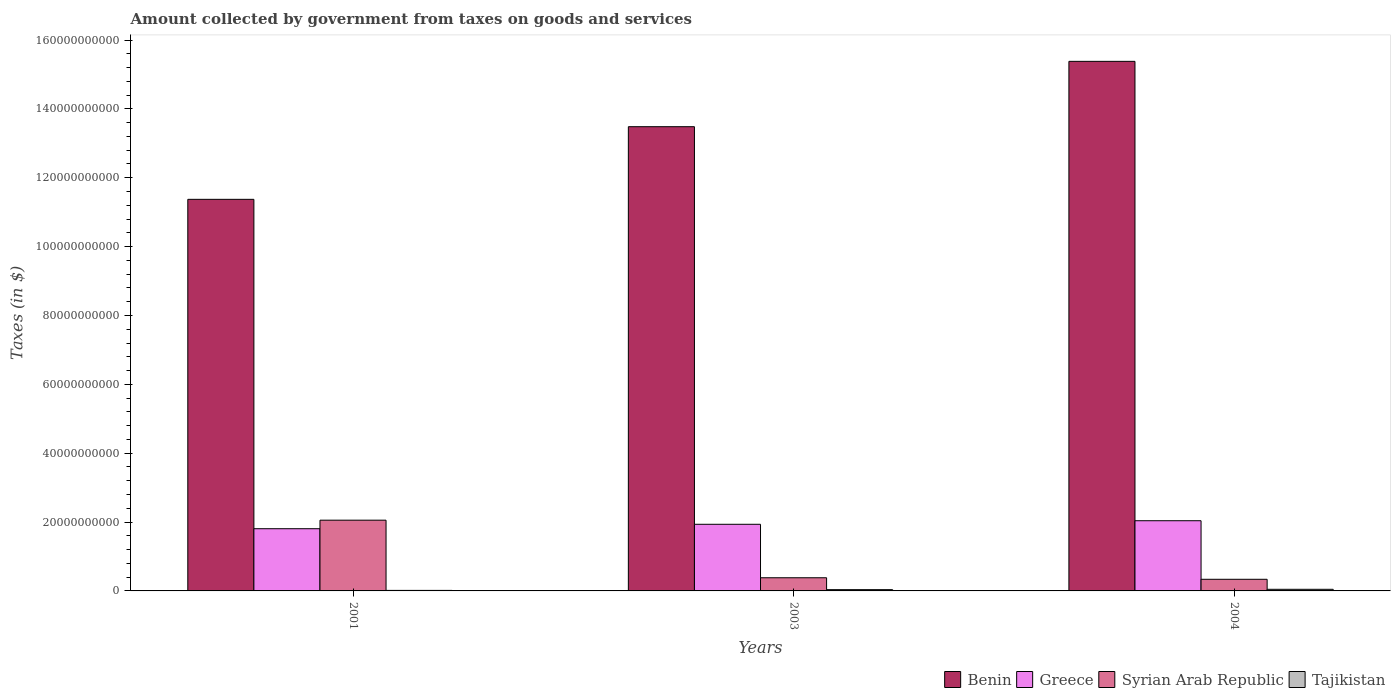Are the number of bars per tick equal to the number of legend labels?
Keep it short and to the point. Yes. How many bars are there on the 1st tick from the left?
Your answer should be compact. 4. In how many cases, is the number of bars for a given year not equal to the number of legend labels?
Make the answer very short. 0. What is the amount collected by government from taxes on goods and services in Tajikistan in 2003?
Your response must be concise. 3.68e+08. Across all years, what is the maximum amount collected by government from taxes on goods and services in Benin?
Make the answer very short. 1.54e+11. Across all years, what is the minimum amount collected by government from taxes on goods and services in Syrian Arab Republic?
Provide a short and direct response. 3.38e+09. In which year was the amount collected by government from taxes on goods and services in Syrian Arab Republic maximum?
Provide a short and direct response. 2001. In which year was the amount collected by government from taxes on goods and services in Syrian Arab Republic minimum?
Keep it short and to the point. 2004. What is the total amount collected by government from taxes on goods and services in Syrian Arab Republic in the graph?
Offer a terse response. 2.77e+1. What is the difference between the amount collected by government from taxes on goods and services in Tajikistan in 2003 and that in 2004?
Offer a very short reply. -1.03e+08. What is the difference between the amount collected by government from taxes on goods and services in Tajikistan in 2003 and the amount collected by government from taxes on goods and services in Greece in 2004?
Provide a short and direct response. -2.00e+1. What is the average amount collected by government from taxes on goods and services in Syrian Arab Republic per year?
Your answer should be very brief. 9.25e+09. In the year 2001, what is the difference between the amount collected by government from taxes on goods and services in Benin and amount collected by government from taxes on goods and services in Tajikistan?
Your answer should be compact. 1.14e+11. What is the ratio of the amount collected by government from taxes on goods and services in Tajikistan in 2001 to that in 2003?
Your response must be concise. 0.42. What is the difference between the highest and the second highest amount collected by government from taxes on goods and services in Benin?
Give a very brief answer. 1.90e+1. What is the difference between the highest and the lowest amount collected by government from taxes on goods and services in Tajikistan?
Your answer should be very brief. 3.17e+08. In how many years, is the amount collected by government from taxes on goods and services in Greece greater than the average amount collected by government from taxes on goods and services in Greece taken over all years?
Your response must be concise. 2. Is the sum of the amount collected by government from taxes on goods and services in Greece in 2001 and 2003 greater than the maximum amount collected by government from taxes on goods and services in Syrian Arab Republic across all years?
Your answer should be very brief. Yes. Is it the case that in every year, the sum of the amount collected by government from taxes on goods and services in Syrian Arab Republic and amount collected by government from taxes on goods and services in Benin is greater than the sum of amount collected by government from taxes on goods and services in Tajikistan and amount collected by government from taxes on goods and services in Greece?
Provide a short and direct response. Yes. What does the 4th bar from the left in 2004 represents?
Offer a terse response. Tajikistan. What does the 1st bar from the right in 2003 represents?
Your answer should be very brief. Tajikistan. Is it the case that in every year, the sum of the amount collected by government from taxes on goods and services in Greece and amount collected by government from taxes on goods and services in Benin is greater than the amount collected by government from taxes on goods and services in Syrian Arab Republic?
Make the answer very short. Yes. How many bars are there?
Offer a very short reply. 12. Are all the bars in the graph horizontal?
Provide a short and direct response. No. How many years are there in the graph?
Make the answer very short. 3. What is the difference between two consecutive major ticks on the Y-axis?
Offer a terse response. 2.00e+1. Does the graph contain any zero values?
Your response must be concise. No. Does the graph contain grids?
Keep it short and to the point. No. Where does the legend appear in the graph?
Keep it short and to the point. Bottom right. How are the legend labels stacked?
Make the answer very short. Horizontal. What is the title of the graph?
Give a very brief answer. Amount collected by government from taxes on goods and services. What is the label or title of the X-axis?
Your response must be concise. Years. What is the label or title of the Y-axis?
Ensure brevity in your answer.  Taxes (in $). What is the Taxes (in $) in Benin in 2001?
Your answer should be compact. 1.14e+11. What is the Taxes (in $) in Greece in 2001?
Provide a short and direct response. 1.81e+1. What is the Taxes (in $) of Syrian Arab Republic in 2001?
Offer a terse response. 2.05e+1. What is the Taxes (in $) of Tajikistan in 2001?
Provide a short and direct response. 1.53e+08. What is the Taxes (in $) in Benin in 2003?
Keep it short and to the point. 1.35e+11. What is the Taxes (in $) of Greece in 2003?
Make the answer very short. 1.94e+1. What is the Taxes (in $) in Syrian Arab Republic in 2003?
Provide a succinct answer. 3.82e+09. What is the Taxes (in $) of Tajikistan in 2003?
Make the answer very short. 3.68e+08. What is the Taxes (in $) of Benin in 2004?
Ensure brevity in your answer.  1.54e+11. What is the Taxes (in $) of Greece in 2004?
Make the answer very short. 2.04e+1. What is the Taxes (in $) of Syrian Arab Republic in 2004?
Provide a short and direct response. 3.38e+09. What is the Taxes (in $) in Tajikistan in 2004?
Make the answer very short. 4.71e+08. Across all years, what is the maximum Taxes (in $) in Benin?
Provide a succinct answer. 1.54e+11. Across all years, what is the maximum Taxes (in $) of Greece?
Give a very brief answer. 2.04e+1. Across all years, what is the maximum Taxes (in $) in Syrian Arab Republic?
Your answer should be very brief. 2.05e+1. Across all years, what is the maximum Taxes (in $) of Tajikistan?
Provide a succinct answer. 4.71e+08. Across all years, what is the minimum Taxes (in $) in Benin?
Offer a very short reply. 1.14e+11. Across all years, what is the minimum Taxes (in $) of Greece?
Offer a terse response. 1.81e+1. Across all years, what is the minimum Taxes (in $) of Syrian Arab Republic?
Your answer should be very brief. 3.38e+09. Across all years, what is the minimum Taxes (in $) of Tajikistan?
Your response must be concise. 1.53e+08. What is the total Taxes (in $) in Benin in the graph?
Your answer should be compact. 4.02e+11. What is the total Taxes (in $) of Greece in the graph?
Give a very brief answer. 5.78e+1. What is the total Taxes (in $) of Syrian Arab Republic in the graph?
Your answer should be very brief. 2.77e+1. What is the total Taxes (in $) in Tajikistan in the graph?
Give a very brief answer. 9.92e+08. What is the difference between the Taxes (in $) in Benin in 2001 and that in 2003?
Keep it short and to the point. -2.11e+1. What is the difference between the Taxes (in $) of Greece in 2001 and that in 2003?
Ensure brevity in your answer.  -1.29e+09. What is the difference between the Taxes (in $) in Syrian Arab Republic in 2001 and that in 2003?
Provide a short and direct response. 1.67e+1. What is the difference between the Taxes (in $) in Tajikistan in 2001 and that in 2003?
Ensure brevity in your answer.  -2.14e+08. What is the difference between the Taxes (in $) of Benin in 2001 and that in 2004?
Your answer should be compact. -4.01e+1. What is the difference between the Taxes (in $) of Greece in 2001 and that in 2004?
Provide a short and direct response. -2.32e+09. What is the difference between the Taxes (in $) in Syrian Arab Republic in 2001 and that in 2004?
Your answer should be compact. 1.72e+1. What is the difference between the Taxes (in $) in Tajikistan in 2001 and that in 2004?
Ensure brevity in your answer.  -3.17e+08. What is the difference between the Taxes (in $) of Benin in 2003 and that in 2004?
Offer a very short reply. -1.90e+1. What is the difference between the Taxes (in $) of Greece in 2003 and that in 2004?
Your answer should be very brief. -1.03e+09. What is the difference between the Taxes (in $) of Syrian Arab Republic in 2003 and that in 2004?
Offer a very short reply. 4.42e+08. What is the difference between the Taxes (in $) in Tajikistan in 2003 and that in 2004?
Offer a terse response. -1.03e+08. What is the difference between the Taxes (in $) of Benin in 2001 and the Taxes (in $) of Greece in 2003?
Provide a succinct answer. 9.44e+1. What is the difference between the Taxes (in $) in Benin in 2001 and the Taxes (in $) in Syrian Arab Republic in 2003?
Your answer should be compact. 1.10e+11. What is the difference between the Taxes (in $) in Benin in 2001 and the Taxes (in $) in Tajikistan in 2003?
Your response must be concise. 1.13e+11. What is the difference between the Taxes (in $) of Greece in 2001 and the Taxes (in $) of Syrian Arab Republic in 2003?
Keep it short and to the point. 1.42e+1. What is the difference between the Taxes (in $) of Greece in 2001 and the Taxes (in $) of Tajikistan in 2003?
Offer a very short reply. 1.77e+1. What is the difference between the Taxes (in $) in Syrian Arab Republic in 2001 and the Taxes (in $) in Tajikistan in 2003?
Your answer should be very brief. 2.02e+1. What is the difference between the Taxes (in $) of Benin in 2001 and the Taxes (in $) of Greece in 2004?
Give a very brief answer. 9.33e+1. What is the difference between the Taxes (in $) in Benin in 2001 and the Taxes (in $) in Syrian Arab Republic in 2004?
Provide a succinct answer. 1.10e+11. What is the difference between the Taxes (in $) in Benin in 2001 and the Taxes (in $) in Tajikistan in 2004?
Your answer should be very brief. 1.13e+11. What is the difference between the Taxes (in $) of Greece in 2001 and the Taxes (in $) of Syrian Arab Republic in 2004?
Give a very brief answer. 1.47e+1. What is the difference between the Taxes (in $) in Greece in 2001 and the Taxes (in $) in Tajikistan in 2004?
Keep it short and to the point. 1.76e+1. What is the difference between the Taxes (in $) of Syrian Arab Republic in 2001 and the Taxes (in $) of Tajikistan in 2004?
Make the answer very short. 2.01e+1. What is the difference between the Taxes (in $) of Benin in 2003 and the Taxes (in $) of Greece in 2004?
Keep it short and to the point. 1.14e+11. What is the difference between the Taxes (in $) of Benin in 2003 and the Taxes (in $) of Syrian Arab Republic in 2004?
Give a very brief answer. 1.31e+11. What is the difference between the Taxes (in $) in Benin in 2003 and the Taxes (in $) in Tajikistan in 2004?
Offer a very short reply. 1.34e+11. What is the difference between the Taxes (in $) in Greece in 2003 and the Taxes (in $) in Syrian Arab Republic in 2004?
Provide a succinct answer. 1.60e+1. What is the difference between the Taxes (in $) of Greece in 2003 and the Taxes (in $) of Tajikistan in 2004?
Offer a very short reply. 1.89e+1. What is the difference between the Taxes (in $) in Syrian Arab Republic in 2003 and the Taxes (in $) in Tajikistan in 2004?
Keep it short and to the point. 3.35e+09. What is the average Taxes (in $) in Benin per year?
Your response must be concise. 1.34e+11. What is the average Taxes (in $) in Greece per year?
Give a very brief answer. 1.93e+1. What is the average Taxes (in $) in Syrian Arab Republic per year?
Your response must be concise. 9.25e+09. What is the average Taxes (in $) of Tajikistan per year?
Keep it short and to the point. 3.31e+08. In the year 2001, what is the difference between the Taxes (in $) of Benin and Taxes (in $) of Greece?
Offer a very short reply. 9.57e+1. In the year 2001, what is the difference between the Taxes (in $) of Benin and Taxes (in $) of Syrian Arab Republic?
Provide a succinct answer. 9.32e+1. In the year 2001, what is the difference between the Taxes (in $) in Benin and Taxes (in $) in Tajikistan?
Provide a short and direct response. 1.14e+11. In the year 2001, what is the difference between the Taxes (in $) in Greece and Taxes (in $) in Syrian Arab Republic?
Ensure brevity in your answer.  -2.48e+09. In the year 2001, what is the difference between the Taxes (in $) in Greece and Taxes (in $) in Tajikistan?
Offer a very short reply. 1.79e+1. In the year 2001, what is the difference between the Taxes (in $) of Syrian Arab Republic and Taxes (in $) of Tajikistan?
Provide a succinct answer. 2.04e+1. In the year 2003, what is the difference between the Taxes (in $) in Benin and Taxes (in $) in Greece?
Keep it short and to the point. 1.15e+11. In the year 2003, what is the difference between the Taxes (in $) of Benin and Taxes (in $) of Syrian Arab Republic?
Keep it short and to the point. 1.31e+11. In the year 2003, what is the difference between the Taxes (in $) in Benin and Taxes (in $) in Tajikistan?
Keep it short and to the point. 1.34e+11. In the year 2003, what is the difference between the Taxes (in $) of Greece and Taxes (in $) of Syrian Arab Republic?
Your answer should be compact. 1.55e+1. In the year 2003, what is the difference between the Taxes (in $) in Greece and Taxes (in $) in Tajikistan?
Make the answer very short. 1.90e+1. In the year 2003, what is the difference between the Taxes (in $) in Syrian Arab Republic and Taxes (in $) in Tajikistan?
Your answer should be very brief. 3.45e+09. In the year 2004, what is the difference between the Taxes (in $) of Benin and Taxes (in $) of Greece?
Keep it short and to the point. 1.33e+11. In the year 2004, what is the difference between the Taxes (in $) of Benin and Taxes (in $) of Syrian Arab Republic?
Make the answer very short. 1.50e+11. In the year 2004, what is the difference between the Taxes (in $) of Benin and Taxes (in $) of Tajikistan?
Your response must be concise. 1.53e+11. In the year 2004, what is the difference between the Taxes (in $) in Greece and Taxes (in $) in Syrian Arab Republic?
Provide a short and direct response. 1.70e+1. In the year 2004, what is the difference between the Taxes (in $) in Greece and Taxes (in $) in Tajikistan?
Give a very brief answer. 1.99e+1. In the year 2004, what is the difference between the Taxes (in $) of Syrian Arab Republic and Taxes (in $) of Tajikistan?
Offer a very short reply. 2.91e+09. What is the ratio of the Taxes (in $) in Benin in 2001 to that in 2003?
Your answer should be compact. 0.84. What is the ratio of the Taxes (in $) of Greece in 2001 to that in 2003?
Give a very brief answer. 0.93. What is the ratio of the Taxes (in $) in Syrian Arab Republic in 2001 to that in 2003?
Keep it short and to the point. 5.38. What is the ratio of the Taxes (in $) in Tajikistan in 2001 to that in 2003?
Your answer should be compact. 0.42. What is the ratio of the Taxes (in $) in Benin in 2001 to that in 2004?
Offer a very short reply. 0.74. What is the ratio of the Taxes (in $) in Greece in 2001 to that in 2004?
Keep it short and to the point. 0.89. What is the ratio of the Taxes (in $) in Syrian Arab Republic in 2001 to that in 2004?
Your answer should be compact. 6.08. What is the ratio of the Taxes (in $) of Tajikistan in 2001 to that in 2004?
Keep it short and to the point. 0.33. What is the ratio of the Taxes (in $) in Benin in 2003 to that in 2004?
Provide a short and direct response. 0.88. What is the ratio of the Taxes (in $) of Greece in 2003 to that in 2004?
Offer a terse response. 0.95. What is the ratio of the Taxes (in $) of Syrian Arab Republic in 2003 to that in 2004?
Give a very brief answer. 1.13. What is the ratio of the Taxes (in $) of Tajikistan in 2003 to that in 2004?
Keep it short and to the point. 0.78. What is the difference between the highest and the second highest Taxes (in $) of Benin?
Provide a short and direct response. 1.90e+1. What is the difference between the highest and the second highest Taxes (in $) of Greece?
Your answer should be compact. 1.03e+09. What is the difference between the highest and the second highest Taxes (in $) in Syrian Arab Republic?
Provide a succinct answer. 1.67e+1. What is the difference between the highest and the second highest Taxes (in $) of Tajikistan?
Keep it short and to the point. 1.03e+08. What is the difference between the highest and the lowest Taxes (in $) in Benin?
Offer a very short reply. 4.01e+1. What is the difference between the highest and the lowest Taxes (in $) of Greece?
Your response must be concise. 2.32e+09. What is the difference between the highest and the lowest Taxes (in $) in Syrian Arab Republic?
Keep it short and to the point. 1.72e+1. What is the difference between the highest and the lowest Taxes (in $) of Tajikistan?
Make the answer very short. 3.17e+08. 